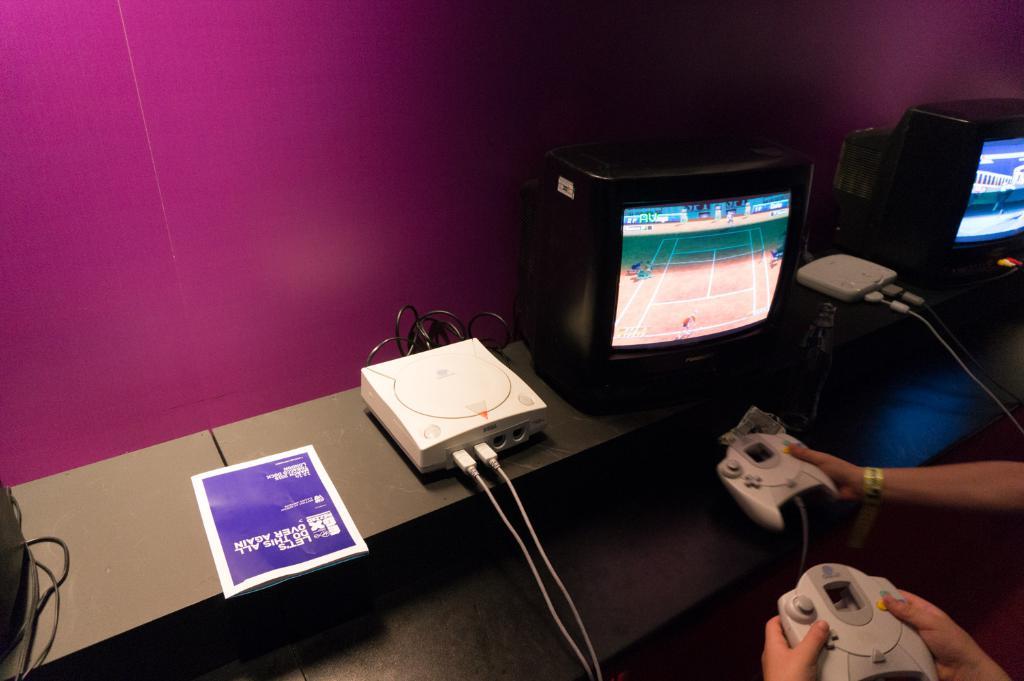What is the colour of the text on the sheet?
Offer a very short reply. Answering does not require reading text in the image. 